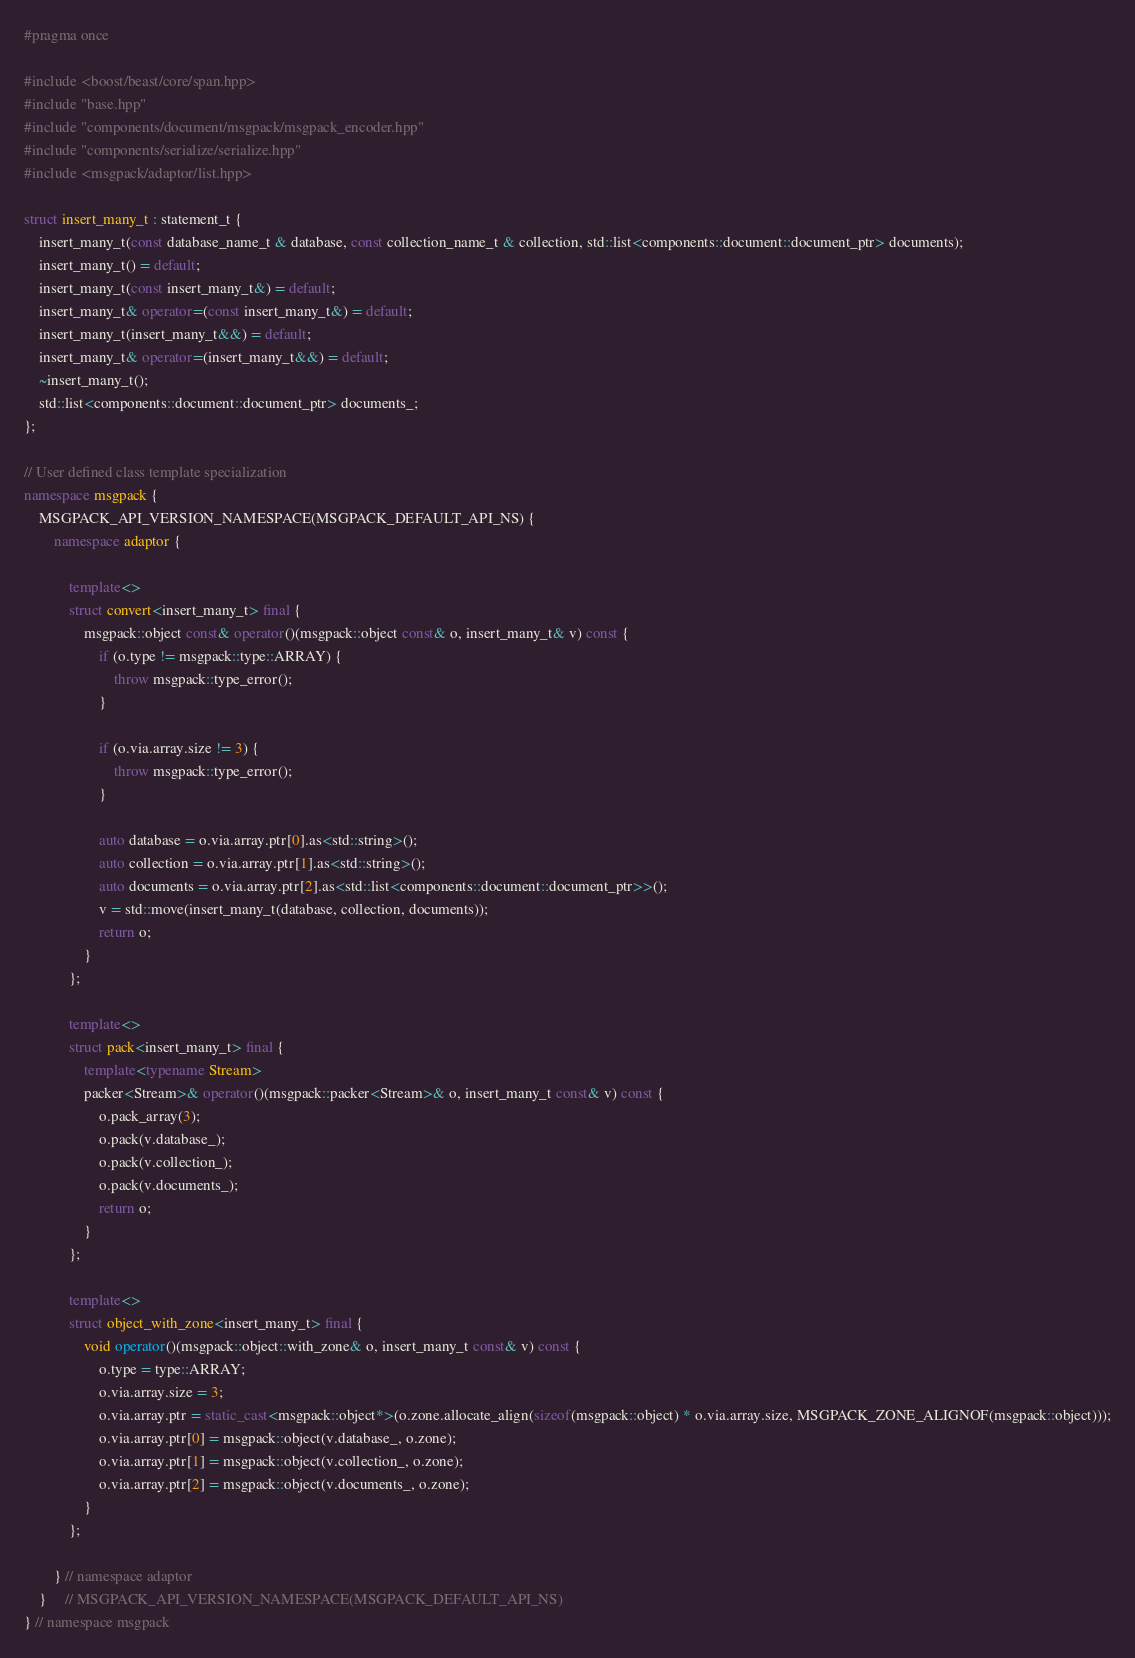<code> <loc_0><loc_0><loc_500><loc_500><_C++_>#pragma once

#include <boost/beast/core/span.hpp>
#include "base.hpp"
#include "components/document/msgpack/msgpack_encoder.hpp"
#include "components/serialize/serialize.hpp"
#include <msgpack/adaptor/list.hpp>

struct insert_many_t : statement_t {
    insert_many_t(const database_name_t & database, const collection_name_t & collection, std::list<components::document::document_ptr> documents);
    insert_many_t() = default;
    insert_many_t(const insert_many_t&) = default;
    insert_many_t& operator=(const insert_many_t&) = default;
    insert_many_t(insert_many_t&&) = default;
    insert_many_t& operator=(insert_many_t&&) = default;
    ~insert_many_t();
    std::list<components::document::document_ptr> documents_;
};

// User defined class template specialization
namespace msgpack {
    MSGPACK_API_VERSION_NAMESPACE(MSGPACK_DEFAULT_API_NS) {
        namespace adaptor {

            template<>
            struct convert<insert_many_t> final {
                msgpack::object const& operator()(msgpack::object const& o, insert_many_t& v) const {
                    if (o.type != msgpack::type::ARRAY) {
                        throw msgpack::type_error();
                    }

                    if (o.via.array.size != 3) {
                        throw msgpack::type_error();
                    }

                    auto database = o.via.array.ptr[0].as<std::string>();
                    auto collection = o.via.array.ptr[1].as<std::string>();
                    auto documents = o.via.array.ptr[2].as<std::list<components::document::document_ptr>>();
                    v = std::move(insert_many_t(database, collection, documents));
                    return o;
                }
            };

            template<>
            struct pack<insert_many_t> final {
                template<typename Stream>
                packer<Stream>& operator()(msgpack::packer<Stream>& o, insert_many_t const& v) const {
                    o.pack_array(3);
                    o.pack(v.database_);
                    o.pack(v.collection_);
                    o.pack(v.documents_);
                    return o;
                }
            };

            template<>
            struct object_with_zone<insert_many_t> final {
                void operator()(msgpack::object::with_zone& o, insert_many_t const& v) const {
                    o.type = type::ARRAY;
                    o.via.array.size = 3;
                    o.via.array.ptr = static_cast<msgpack::object*>(o.zone.allocate_align(sizeof(msgpack::object) * o.via.array.size, MSGPACK_ZONE_ALIGNOF(msgpack::object)));
                    o.via.array.ptr[0] = msgpack::object(v.database_, o.zone);
                    o.via.array.ptr[1] = msgpack::object(v.collection_, o.zone);
                    o.via.array.ptr[2] = msgpack::object(v.documents_, o.zone);
                }
            };

        } // namespace adaptor
    }     // MSGPACK_API_VERSION_NAMESPACE(MSGPACK_DEFAULT_API_NS)
} // namespace msgpack
</code> 